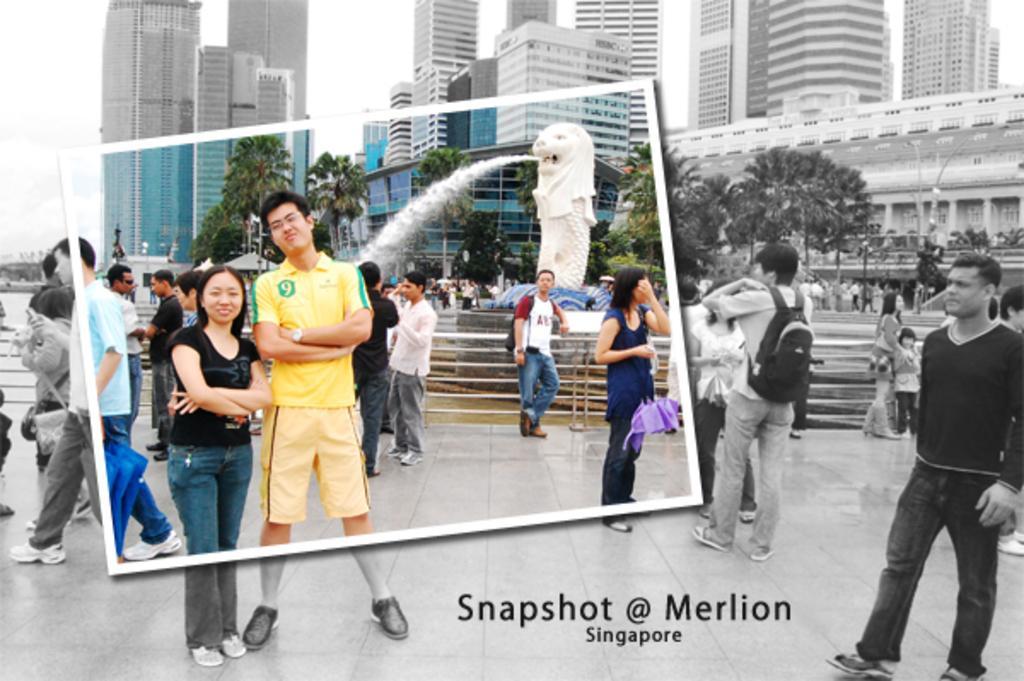Could you give a brief overview of what you see in this image? In this image, there are a few people. We can see the ground and the fence. We can see some trees, buildings, poles. We can also see the fountain. We can see the sky. We can also see some text at the bottom. 